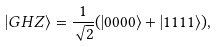<formula> <loc_0><loc_0><loc_500><loc_500>| G H Z \rangle = \frac { 1 } { \sqrt { 2 } } ( | 0 0 0 0 \rangle + | 1 1 1 1 \rangle ) ,</formula> 